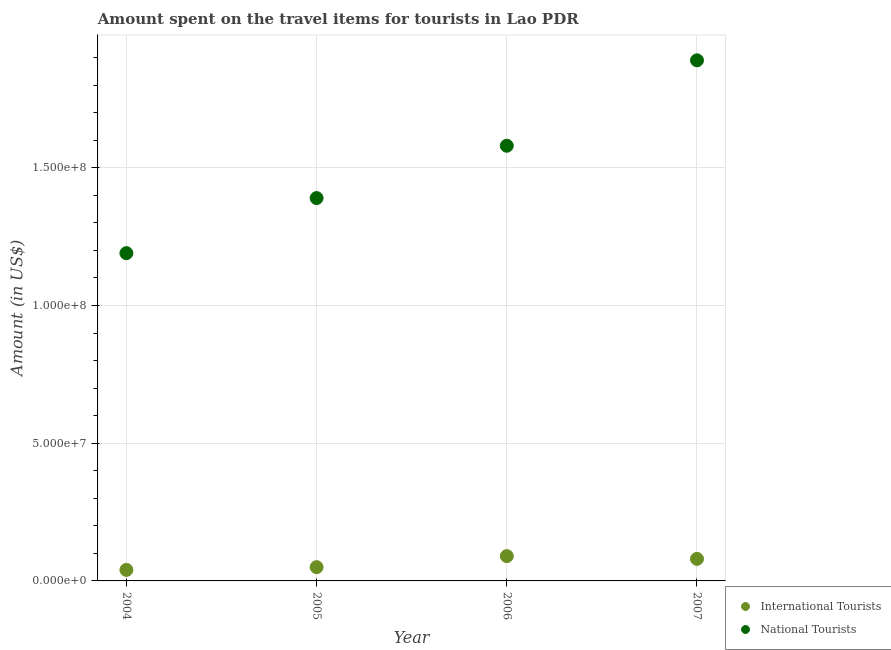How many different coloured dotlines are there?
Your response must be concise. 2. What is the amount spent on travel items of national tourists in 2004?
Provide a succinct answer. 1.19e+08. Across all years, what is the maximum amount spent on travel items of national tourists?
Make the answer very short. 1.89e+08. Across all years, what is the minimum amount spent on travel items of national tourists?
Provide a succinct answer. 1.19e+08. What is the total amount spent on travel items of international tourists in the graph?
Your response must be concise. 2.60e+07. What is the difference between the amount spent on travel items of national tourists in 2004 and that in 2005?
Provide a succinct answer. -2.00e+07. What is the difference between the amount spent on travel items of national tourists in 2007 and the amount spent on travel items of international tourists in 2006?
Your answer should be compact. 1.80e+08. What is the average amount spent on travel items of international tourists per year?
Give a very brief answer. 6.50e+06. In the year 2005, what is the difference between the amount spent on travel items of international tourists and amount spent on travel items of national tourists?
Give a very brief answer. -1.34e+08. What is the ratio of the amount spent on travel items of international tourists in 2004 to that in 2006?
Provide a short and direct response. 0.44. Is the amount spent on travel items of international tourists in 2004 less than that in 2006?
Offer a terse response. Yes. What is the difference between the highest and the second highest amount spent on travel items of national tourists?
Your answer should be very brief. 3.10e+07. What is the difference between the highest and the lowest amount spent on travel items of international tourists?
Provide a succinct answer. 5.00e+06. In how many years, is the amount spent on travel items of national tourists greater than the average amount spent on travel items of national tourists taken over all years?
Make the answer very short. 2. Is the amount spent on travel items of international tourists strictly less than the amount spent on travel items of national tourists over the years?
Make the answer very short. Yes. What is the difference between two consecutive major ticks on the Y-axis?
Ensure brevity in your answer.  5.00e+07. Are the values on the major ticks of Y-axis written in scientific E-notation?
Offer a terse response. Yes. Does the graph contain grids?
Your answer should be very brief. Yes. Where does the legend appear in the graph?
Give a very brief answer. Bottom right. How many legend labels are there?
Your answer should be compact. 2. What is the title of the graph?
Provide a succinct answer. Amount spent on the travel items for tourists in Lao PDR. Does "Public credit registry" appear as one of the legend labels in the graph?
Ensure brevity in your answer.  No. What is the label or title of the X-axis?
Keep it short and to the point. Year. What is the Amount (in US$) in National Tourists in 2004?
Your answer should be compact. 1.19e+08. What is the Amount (in US$) in National Tourists in 2005?
Give a very brief answer. 1.39e+08. What is the Amount (in US$) of International Tourists in 2006?
Your answer should be compact. 9.00e+06. What is the Amount (in US$) in National Tourists in 2006?
Provide a succinct answer. 1.58e+08. What is the Amount (in US$) of International Tourists in 2007?
Your response must be concise. 8.00e+06. What is the Amount (in US$) in National Tourists in 2007?
Ensure brevity in your answer.  1.89e+08. Across all years, what is the maximum Amount (in US$) of International Tourists?
Provide a short and direct response. 9.00e+06. Across all years, what is the maximum Amount (in US$) of National Tourists?
Make the answer very short. 1.89e+08. Across all years, what is the minimum Amount (in US$) in National Tourists?
Your answer should be very brief. 1.19e+08. What is the total Amount (in US$) of International Tourists in the graph?
Provide a short and direct response. 2.60e+07. What is the total Amount (in US$) in National Tourists in the graph?
Your answer should be compact. 6.05e+08. What is the difference between the Amount (in US$) in National Tourists in 2004 and that in 2005?
Give a very brief answer. -2.00e+07. What is the difference between the Amount (in US$) of International Tourists in 2004 and that in 2006?
Your answer should be very brief. -5.00e+06. What is the difference between the Amount (in US$) in National Tourists in 2004 and that in 2006?
Ensure brevity in your answer.  -3.90e+07. What is the difference between the Amount (in US$) in National Tourists in 2004 and that in 2007?
Ensure brevity in your answer.  -7.00e+07. What is the difference between the Amount (in US$) of National Tourists in 2005 and that in 2006?
Keep it short and to the point. -1.90e+07. What is the difference between the Amount (in US$) in National Tourists in 2005 and that in 2007?
Give a very brief answer. -5.00e+07. What is the difference between the Amount (in US$) of National Tourists in 2006 and that in 2007?
Offer a terse response. -3.10e+07. What is the difference between the Amount (in US$) of International Tourists in 2004 and the Amount (in US$) of National Tourists in 2005?
Your answer should be compact. -1.35e+08. What is the difference between the Amount (in US$) in International Tourists in 2004 and the Amount (in US$) in National Tourists in 2006?
Offer a terse response. -1.54e+08. What is the difference between the Amount (in US$) of International Tourists in 2004 and the Amount (in US$) of National Tourists in 2007?
Your answer should be compact. -1.85e+08. What is the difference between the Amount (in US$) in International Tourists in 2005 and the Amount (in US$) in National Tourists in 2006?
Ensure brevity in your answer.  -1.53e+08. What is the difference between the Amount (in US$) of International Tourists in 2005 and the Amount (in US$) of National Tourists in 2007?
Give a very brief answer. -1.84e+08. What is the difference between the Amount (in US$) of International Tourists in 2006 and the Amount (in US$) of National Tourists in 2007?
Your response must be concise. -1.80e+08. What is the average Amount (in US$) of International Tourists per year?
Provide a short and direct response. 6.50e+06. What is the average Amount (in US$) in National Tourists per year?
Ensure brevity in your answer.  1.51e+08. In the year 2004, what is the difference between the Amount (in US$) of International Tourists and Amount (in US$) of National Tourists?
Offer a very short reply. -1.15e+08. In the year 2005, what is the difference between the Amount (in US$) of International Tourists and Amount (in US$) of National Tourists?
Ensure brevity in your answer.  -1.34e+08. In the year 2006, what is the difference between the Amount (in US$) in International Tourists and Amount (in US$) in National Tourists?
Provide a succinct answer. -1.49e+08. In the year 2007, what is the difference between the Amount (in US$) of International Tourists and Amount (in US$) of National Tourists?
Provide a succinct answer. -1.81e+08. What is the ratio of the Amount (in US$) in National Tourists in 2004 to that in 2005?
Offer a terse response. 0.86. What is the ratio of the Amount (in US$) in International Tourists in 2004 to that in 2006?
Your answer should be compact. 0.44. What is the ratio of the Amount (in US$) in National Tourists in 2004 to that in 2006?
Offer a very short reply. 0.75. What is the ratio of the Amount (in US$) of National Tourists in 2004 to that in 2007?
Offer a terse response. 0.63. What is the ratio of the Amount (in US$) of International Tourists in 2005 to that in 2006?
Your response must be concise. 0.56. What is the ratio of the Amount (in US$) of National Tourists in 2005 to that in 2006?
Provide a short and direct response. 0.88. What is the ratio of the Amount (in US$) in International Tourists in 2005 to that in 2007?
Ensure brevity in your answer.  0.62. What is the ratio of the Amount (in US$) of National Tourists in 2005 to that in 2007?
Your response must be concise. 0.74. What is the ratio of the Amount (in US$) of National Tourists in 2006 to that in 2007?
Give a very brief answer. 0.84. What is the difference between the highest and the second highest Amount (in US$) in International Tourists?
Offer a very short reply. 1.00e+06. What is the difference between the highest and the second highest Amount (in US$) in National Tourists?
Offer a terse response. 3.10e+07. What is the difference between the highest and the lowest Amount (in US$) of National Tourists?
Offer a terse response. 7.00e+07. 